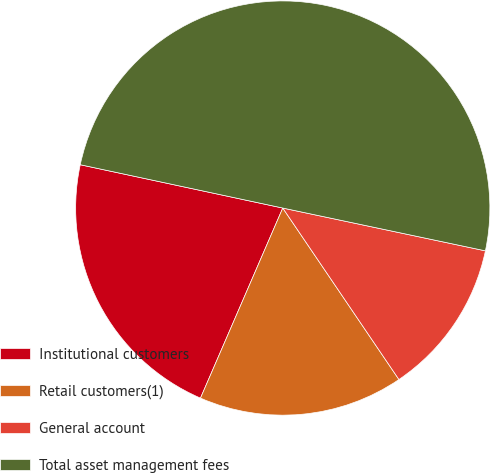<chart> <loc_0><loc_0><loc_500><loc_500><pie_chart><fcel>Institutional customers<fcel>Retail customers(1)<fcel>General account<fcel>Total asset management fees<nl><fcel>21.85%<fcel>15.98%<fcel>12.21%<fcel>49.96%<nl></chart> 